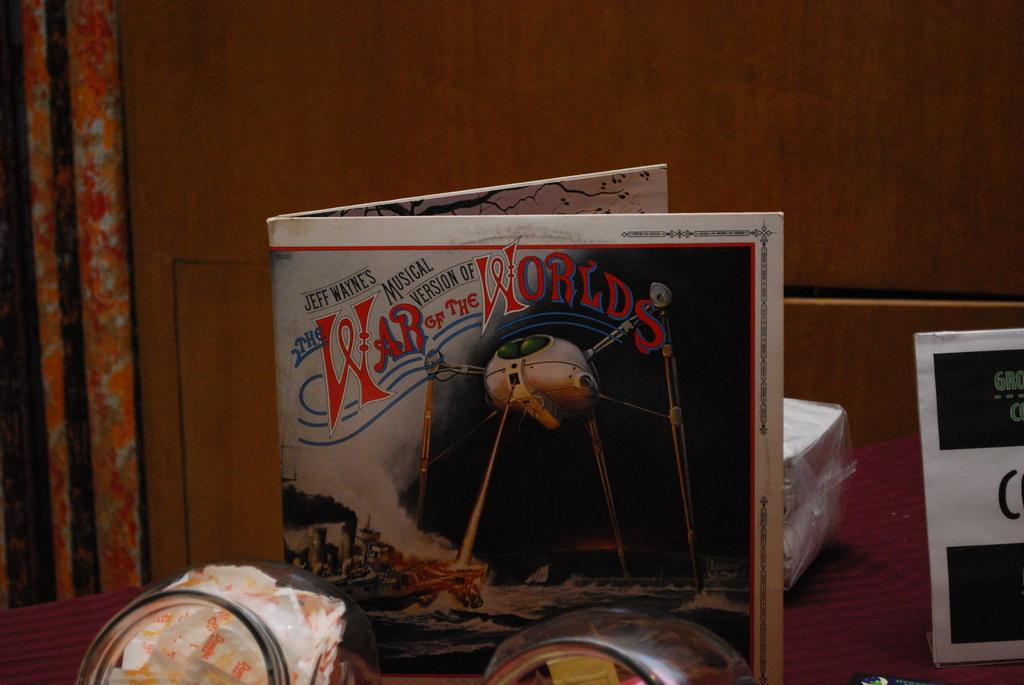<image>
Give a short and clear explanation of the subsequent image. An album titled Jeff Wayne's Musical Version of The War of the Worlds. 